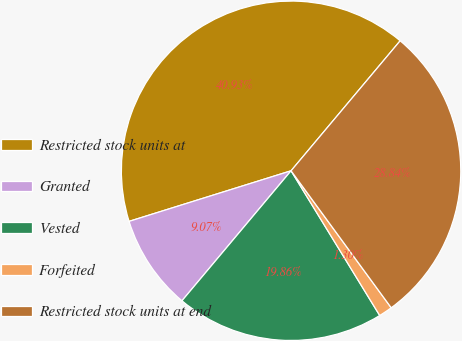Convert chart to OTSL. <chart><loc_0><loc_0><loc_500><loc_500><pie_chart><fcel>Restricted stock units at<fcel>Granted<fcel>Vested<fcel>Forfeited<fcel>Restricted stock units at end<nl><fcel>40.93%<fcel>9.07%<fcel>19.86%<fcel>1.3%<fcel>28.84%<nl></chart> 